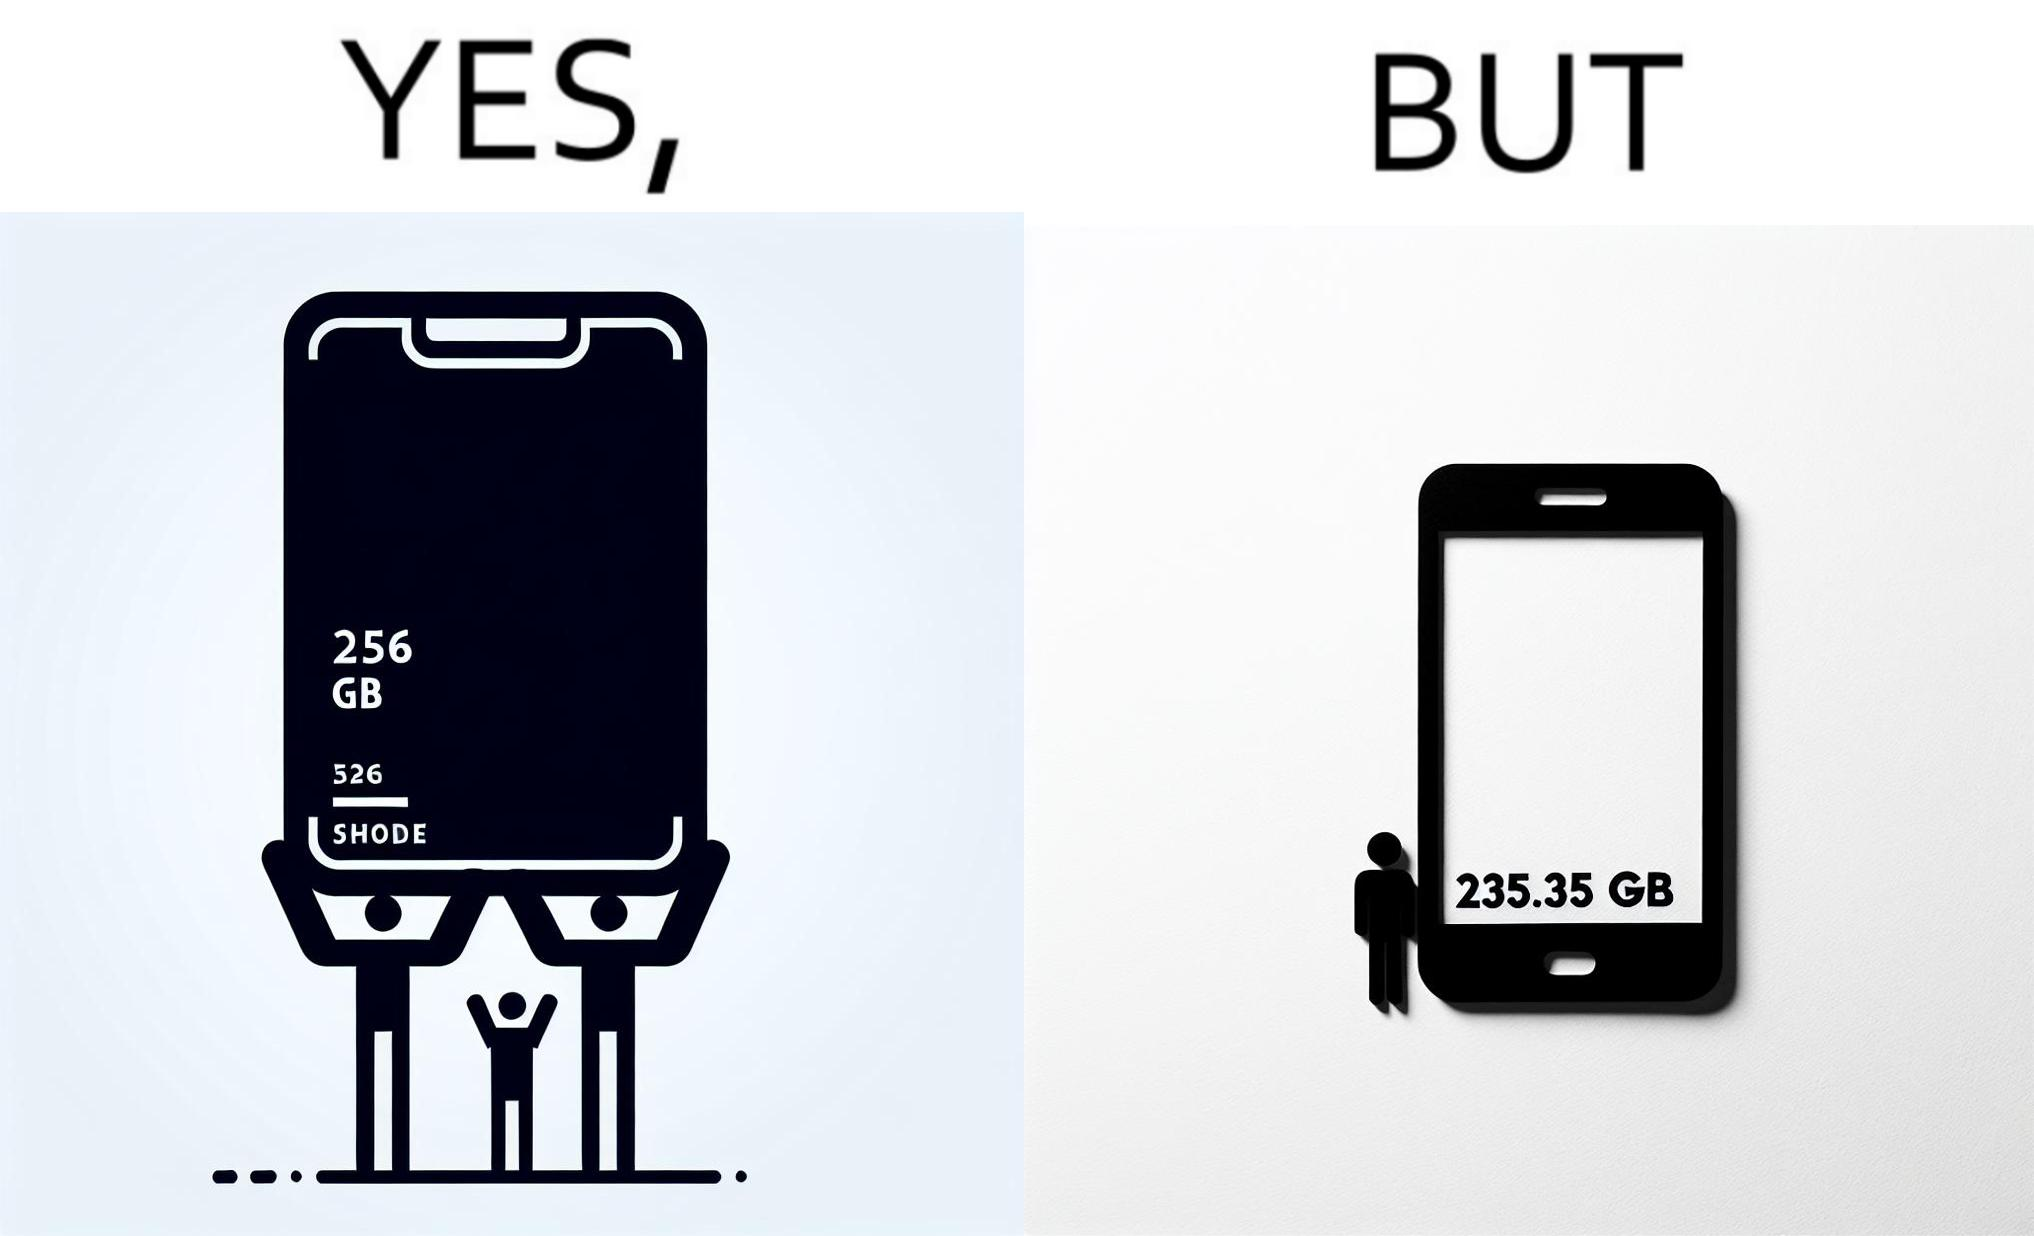Describe what you see in the left and right parts of this image. In the left part of the image: It is a smartphone box claiming the phone has a storage capacity of 256 gb In the right part of the image: It is a smartphone with 235.35 gb of available space 